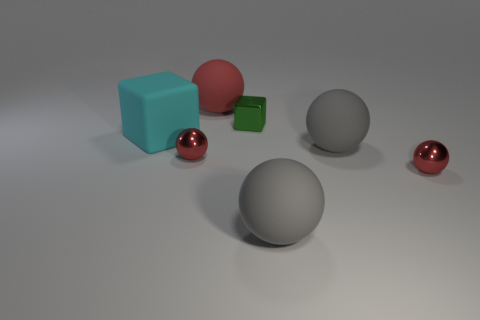What number of other objects are there of the same material as the big cyan thing? 3 